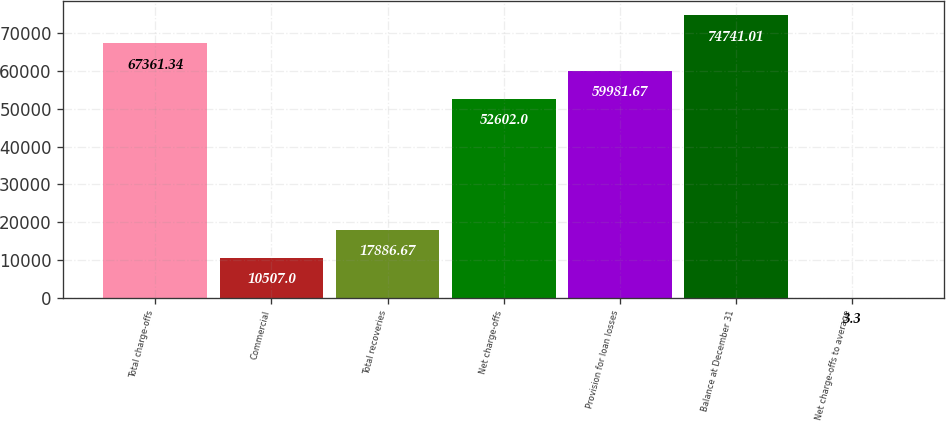Convert chart. <chart><loc_0><loc_0><loc_500><loc_500><bar_chart><fcel>Total charge-offs<fcel>Commercial<fcel>Total recoveries<fcel>Net charge-offs<fcel>Provision for loan losses<fcel>Balance at December 31<fcel>Net charge-offs to average<nl><fcel>67361.3<fcel>10507<fcel>17886.7<fcel>52602<fcel>59981.7<fcel>74741<fcel>3.3<nl></chart> 